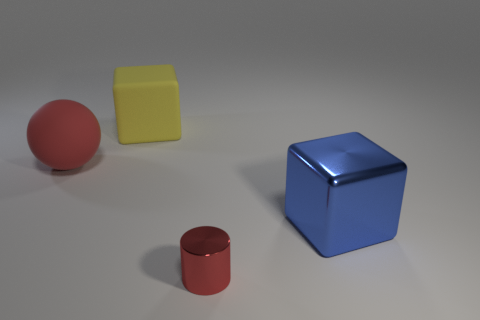Add 1 tiny cyan rubber spheres. How many objects exist? 5 Subtract all cylinders. How many objects are left? 3 Subtract 0 brown cylinders. How many objects are left? 4 Subtract all metal cylinders. Subtract all yellow rubber blocks. How many objects are left? 2 Add 4 tiny objects. How many tiny objects are left? 5 Add 2 large brown rubber things. How many large brown rubber things exist? 2 